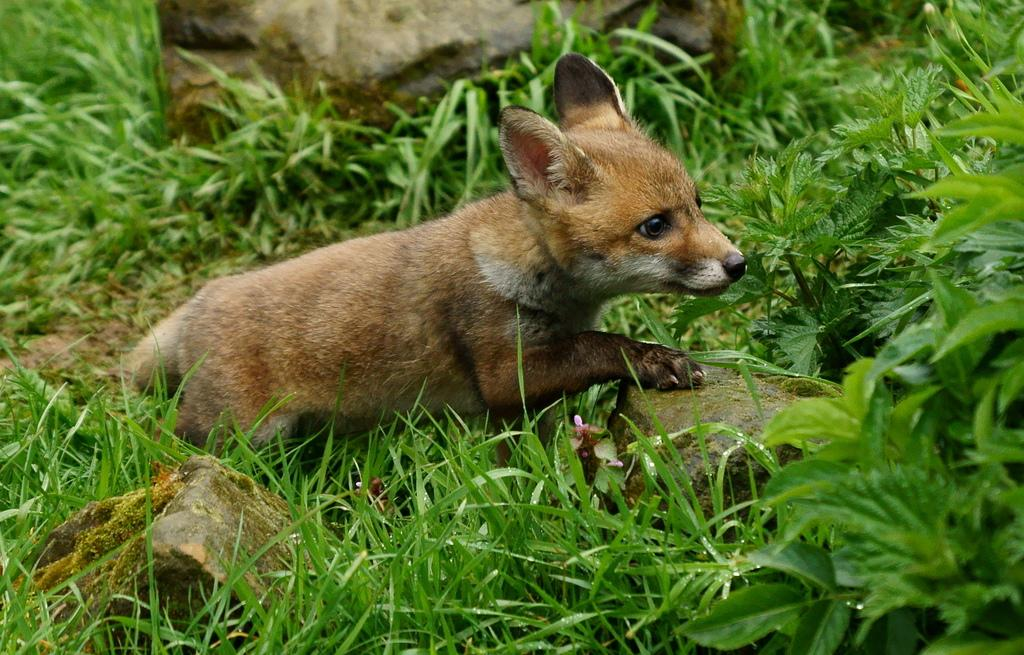What type of animal is in the image? There is a swift fox in the image. What is the color of the swift fox? The swift fox is brown in color. What type of terrain is visible in the image? There is grass on the ground in the image. What other natural elements can be seen in the image? There are rocks visible in the image. How does the swift fox compare to a flame in the image? There is no flame present in the image, so it is not possible to make a comparison between the swift fox and a flame. What type of farewell is the swift fox giving in the image? There is no indication in the image that the swift fox is giving a farewell or saying "good-bye." 